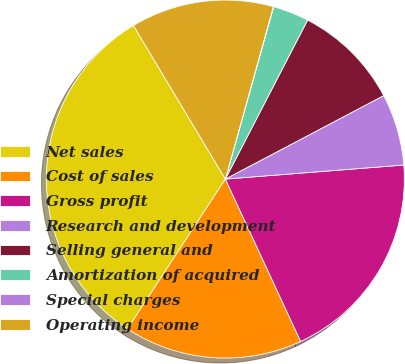Convert chart to OTSL. <chart><loc_0><loc_0><loc_500><loc_500><pie_chart><fcel>Net sales<fcel>Cost of sales<fcel>Gross profit<fcel>Research and development<fcel>Selling general and<fcel>Amortization of acquired<fcel>Special charges<fcel>Operating income<nl><fcel>32.21%<fcel>16.12%<fcel>19.34%<fcel>6.47%<fcel>9.68%<fcel>3.25%<fcel>0.03%<fcel>12.9%<nl></chart> 